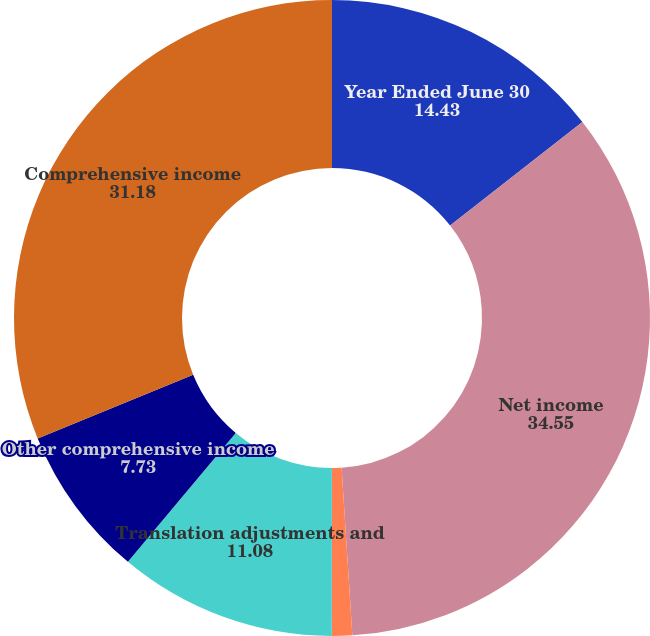Convert chart to OTSL. <chart><loc_0><loc_0><loc_500><loc_500><pie_chart><fcel>Year Ended June 30<fcel>Net income<fcel>Net unrealized gains (losses)<fcel>Translation adjustments and<fcel>Other comprehensive income<fcel>Comprehensive income<nl><fcel>14.43%<fcel>34.55%<fcel>1.03%<fcel>11.08%<fcel>7.73%<fcel>31.18%<nl></chart> 